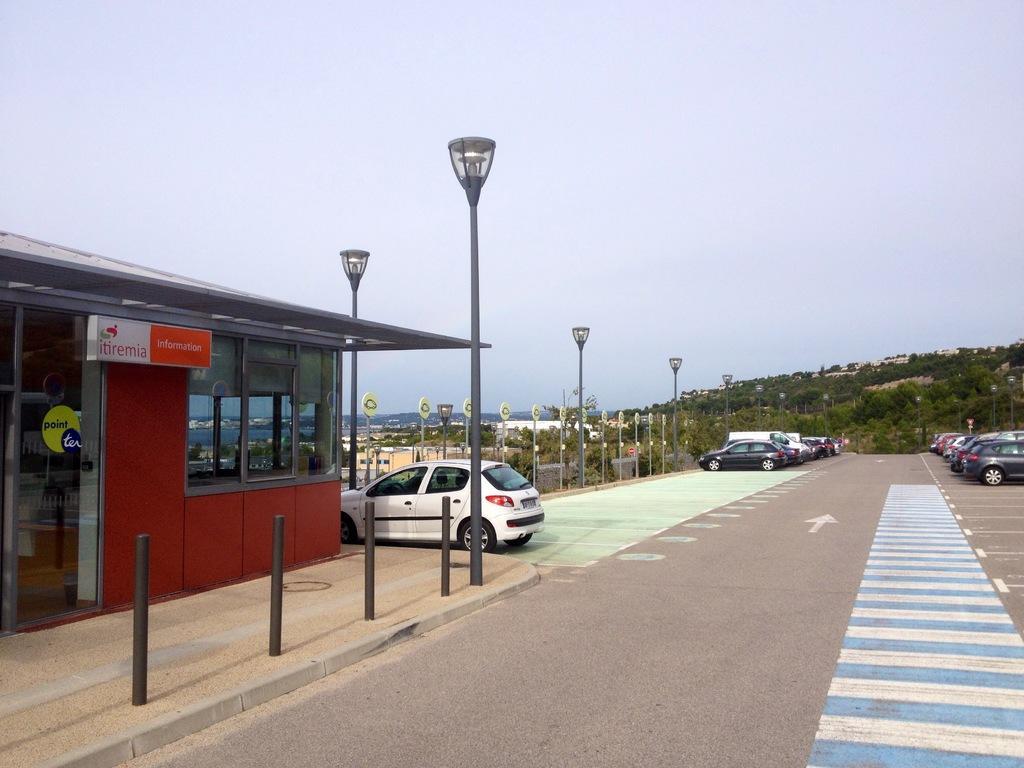In one or two sentences, can you explain what this image depicts? In the left side it is a glass house and a car is parked which is in white color. This is the road in the middle, there are trees. 